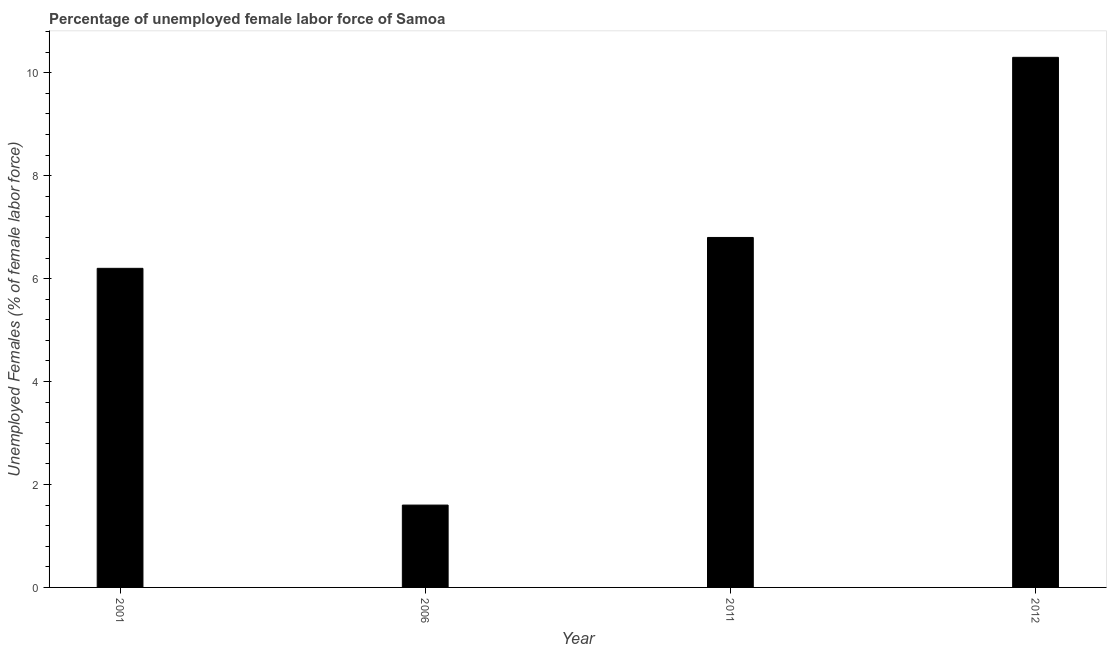What is the title of the graph?
Your answer should be compact. Percentage of unemployed female labor force of Samoa. What is the label or title of the Y-axis?
Offer a very short reply. Unemployed Females (% of female labor force). What is the total unemployed female labour force in 2012?
Offer a terse response. 10.3. Across all years, what is the maximum total unemployed female labour force?
Ensure brevity in your answer.  10.3. Across all years, what is the minimum total unemployed female labour force?
Provide a short and direct response. 1.6. In which year was the total unemployed female labour force maximum?
Offer a terse response. 2012. What is the sum of the total unemployed female labour force?
Your answer should be compact. 24.9. What is the average total unemployed female labour force per year?
Provide a short and direct response. 6.22. Do a majority of the years between 2006 and 2012 (inclusive) have total unemployed female labour force greater than 4.4 %?
Ensure brevity in your answer.  Yes. What is the ratio of the total unemployed female labour force in 2006 to that in 2011?
Provide a short and direct response. 0.23. Is the total unemployed female labour force in 2006 less than that in 2011?
Offer a very short reply. Yes. Is the difference between the total unemployed female labour force in 2006 and 2011 greater than the difference between any two years?
Your answer should be very brief. No. What is the difference between the highest and the second highest total unemployed female labour force?
Offer a very short reply. 3.5. Is the sum of the total unemployed female labour force in 2011 and 2012 greater than the maximum total unemployed female labour force across all years?
Keep it short and to the point. Yes. What is the difference between the highest and the lowest total unemployed female labour force?
Offer a terse response. 8.7. How many bars are there?
Your answer should be compact. 4. Are all the bars in the graph horizontal?
Make the answer very short. No. What is the difference between two consecutive major ticks on the Y-axis?
Offer a terse response. 2. What is the Unemployed Females (% of female labor force) in 2001?
Provide a succinct answer. 6.2. What is the Unemployed Females (% of female labor force) of 2006?
Your answer should be very brief. 1.6. What is the Unemployed Females (% of female labor force) of 2011?
Offer a terse response. 6.8. What is the Unemployed Females (% of female labor force) in 2012?
Your answer should be very brief. 10.3. What is the difference between the Unemployed Females (% of female labor force) in 2001 and 2006?
Provide a succinct answer. 4.6. What is the difference between the Unemployed Females (% of female labor force) in 2001 and 2011?
Provide a succinct answer. -0.6. What is the difference between the Unemployed Females (% of female labor force) in 2001 and 2012?
Your answer should be compact. -4.1. What is the difference between the Unemployed Females (% of female labor force) in 2006 and 2012?
Give a very brief answer. -8.7. What is the ratio of the Unemployed Females (% of female labor force) in 2001 to that in 2006?
Offer a very short reply. 3.88. What is the ratio of the Unemployed Females (% of female labor force) in 2001 to that in 2011?
Your response must be concise. 0.91. What is the ratio of the Unemployed Females (% of female labor force) in 2001 to that in 2012?
Ensure brevity in your answer.  0.6. What is the ratio of the Unemployed Females (% of female labor force) in 2006 to that in 2011?
Your answer should be compact. 0.23. What is the ratio of the Unemployed Females (% of female labor force) in 2006 to that in 2012?
Ensure brevity in your answer.  0.15. What is the ratio of the Unemployed Females (% of female labor force) in 2011 to that in 2012?
Provide a short and direct response. 0.66. 